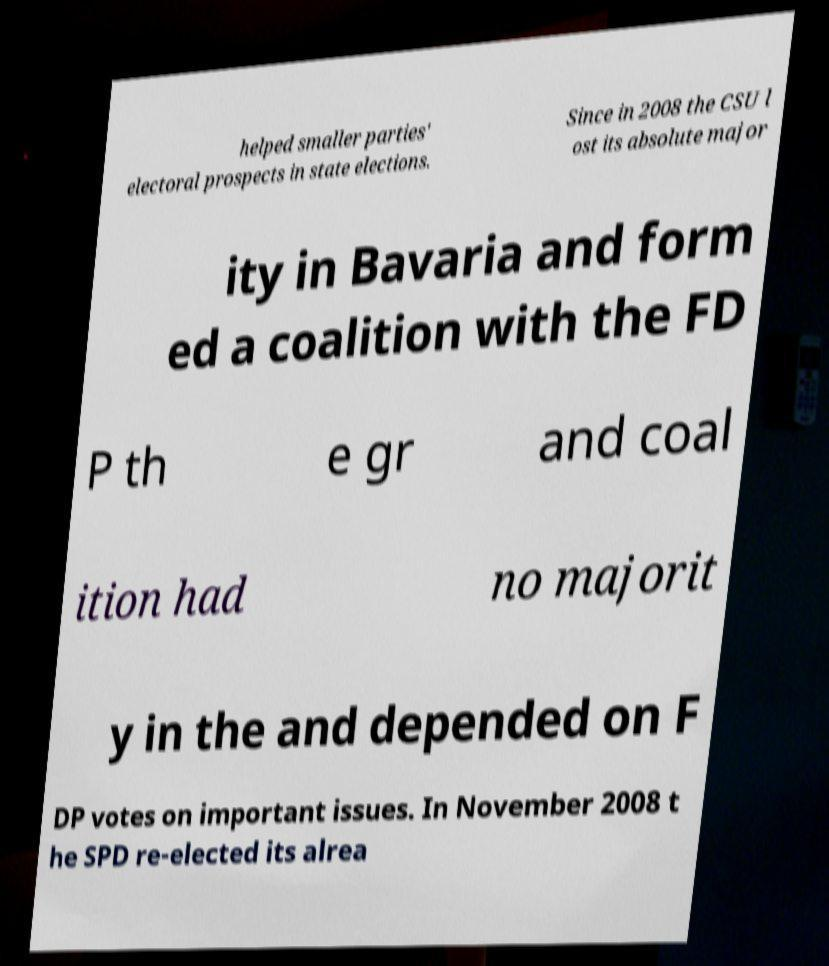Could you assist in decoding the text presented in this image and type it out clearly? helped smaller parties' electoral prospects in state elections. Since in 2008 the CSU l ost its absolute major ity in Bavaria and form ed a coalition with the FD P th e gr and coal ition had no majorit y in the and depended on F DP votes on important issues. In November 2008 t he SPD re-elected its alrea 